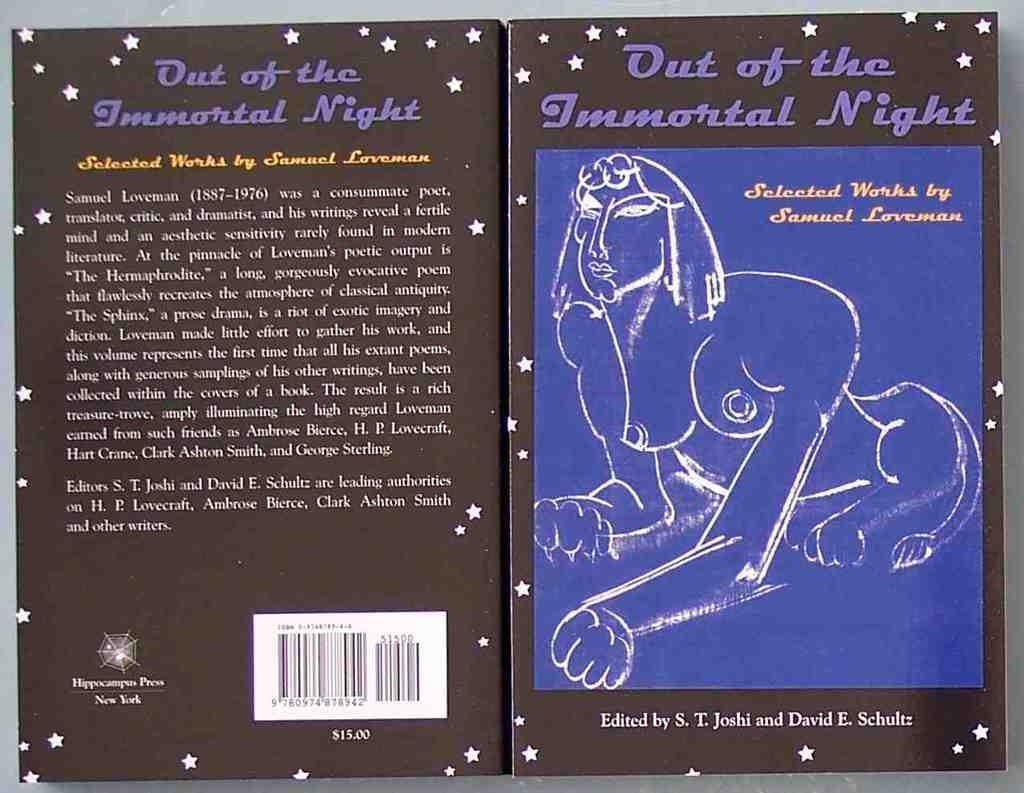<image>
Offer a succinct explanation of the picture presented. The front and back covers of Out of the Immortal night by Samuel Loveman is shown 